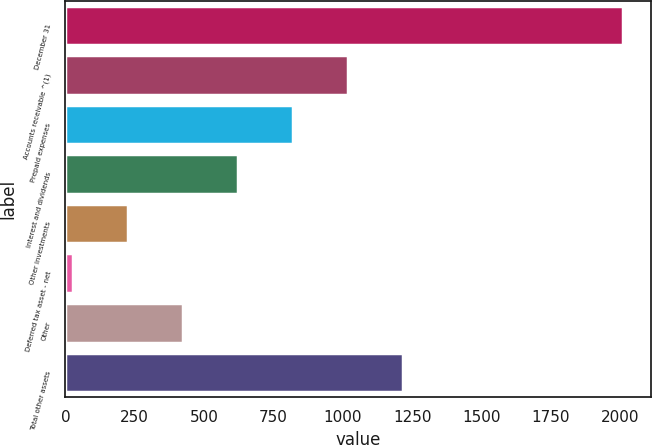<chart> <loc_0><loc_0><loc_500><loc_500><bar_chart><fcel>December 31<fcel>Accounts receivable ^(1)<fcel>Prepaid expenses<fcel>Interest and dividends<fcel>Other investments<fcel>Deferred tax asset - net<fcel>Other<fcel>Total other assets<nl><fcel>2011<fcel>1019<fcel>820.6<fcel>622.2<fcel>225.4<fcel>27<fcel>423.8<fcel>1217.4<nl></chart> 